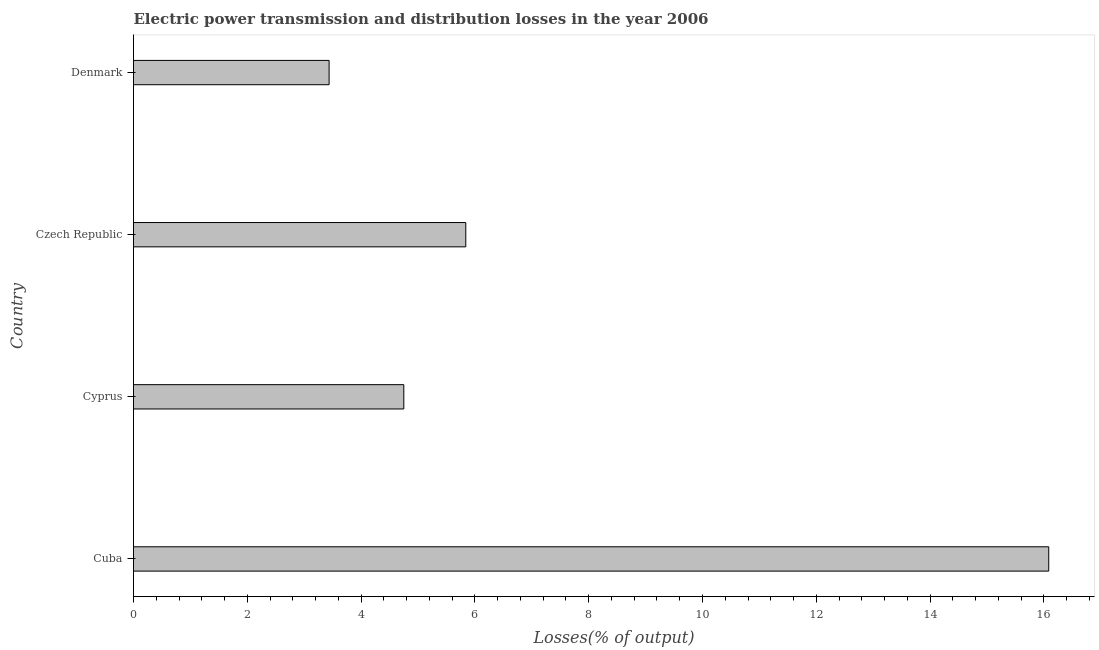What is the title of the graph?
Offer a very short reply. Electric power transmission and distribution losses in the year 2006. What is the label or title of the X-axis?
Offer a terse response. Losses(% of output). What is the label or title of the Y-axis?
Ensure brevity in your answer.  Country. What is the electric power transmission and distribution losses in Cuba?
Ensure brevity in your answer.  16.08. Across all countries, what is the maximum electric power transmission and distribution losses?
Your response must be concise. 16.08. Across all countries, what is the minimum electric power transmission and distribution losses?
Ensure brevity in your answer.  3.44. In which country was the electric power transmission and distribution losses maximum?
Your answer should be compact. Cuba. In which country was the electric power transmission and distribution losses minimum?
Your answer should be compact. Denmark. What is the sum of the electric power transmission and distribution losses?
Offer a very short reply. 30.11. What is the difference between the electric power transmission and distribution losses in Czech Republic and Denmark?
Make the answer very short. 2.4. What is the average electric power transmission and distribution losses per country?
Keep it short and to the point. 7.53. What is the median electric power transmission and distribution losses?
Provide a short and direct response. 5.3. In how many countries, is the electric power transmission and distribution losses greater than 16.4 %?
Ensure brevity in your answer.  0. What is the ratio of the electric power transmission and distribution losses in Czech Republic to that in Denmark?
Your answer should be compact. 1.7. What is the difference between the highest and the second highest electric power transmission and distribution losses?
Provide a succinct answer. 10.24. What is the difference between the highest and the lowest electric power transmission and distribution losses?
Your answer should be compact. 12.65. Are all the bars in the graph horizontal?
Make the answer very short. Yes. What is the difference between two consecutive major ticks on the X-axis?
Ensure brevity in your answer.  2. Are the values on the major ticks of X-axis written in scientific E-notation?
Make the answer very short. No. What is the Losses(% of output) in Cuba?
Your answer should be compact. 16.08. What is the Losses(% of output) of Cyprus?
Provide a short and direct response. 4.75. What is the Losses(% of output) in Czech Republic?
Give a very brief answer. 5.84. What is the Losses(% of output) of Denmark?
Give a very brief answer. 3.44. What is the difference between the Losses(% of output) in Cuba and Cyprus?
Provide a short and direct response. 11.33. What is the difference between the Losses(% of output) in Cuba and Czech Republic?
Make the answer very short. 10.25. What is the difference between the Losses(% of output) in Cuba and Denmark?
Give a very brief answer. 12.65. What is the difference between the Losses(% of output) in Cyprus and Czech Republic?
Make the answer very short. -1.09. What is the difference between the Losses(% of output) in Cyprus and Denmark?
Make the answer very short. 1.31. What is the difference between the Losses(% of output) in Czech Republic and Denmark?
Your answer should be compact. 2.4. What is the ratio of the Losses(% of output) in Cuba to that in Cyprus?
Make the answer very short. 3.39. What is the ratio of the Losses(% of output) in Cuba to that in Czech Republic?
Offer a very short reply. 2.75. What is the ratio of the Losses(% of output) in Cuba to that in Denmark?
Your answer should be compact. 4.68. What is the ratio of the Losses(% of output) in Cyprus to that in Czech Republic?
Your response must be concise. 0.81. What is the ratio of the Losses(% of output) in Cyprus to that in Denmark?
Provide a succinct answer. 1.38. What is the ratio of the Losses(% of output) in Czech Republic to that in Denmark?
Keep it short and to the point. 1.7. 